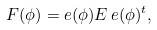Convert formula to latex. <formula><loc_0><loc_0><loc_500><loc_500>F ( \phi ) = e ( \phi ) E \, e ( \phi ) ^ { t } ,</formula> 